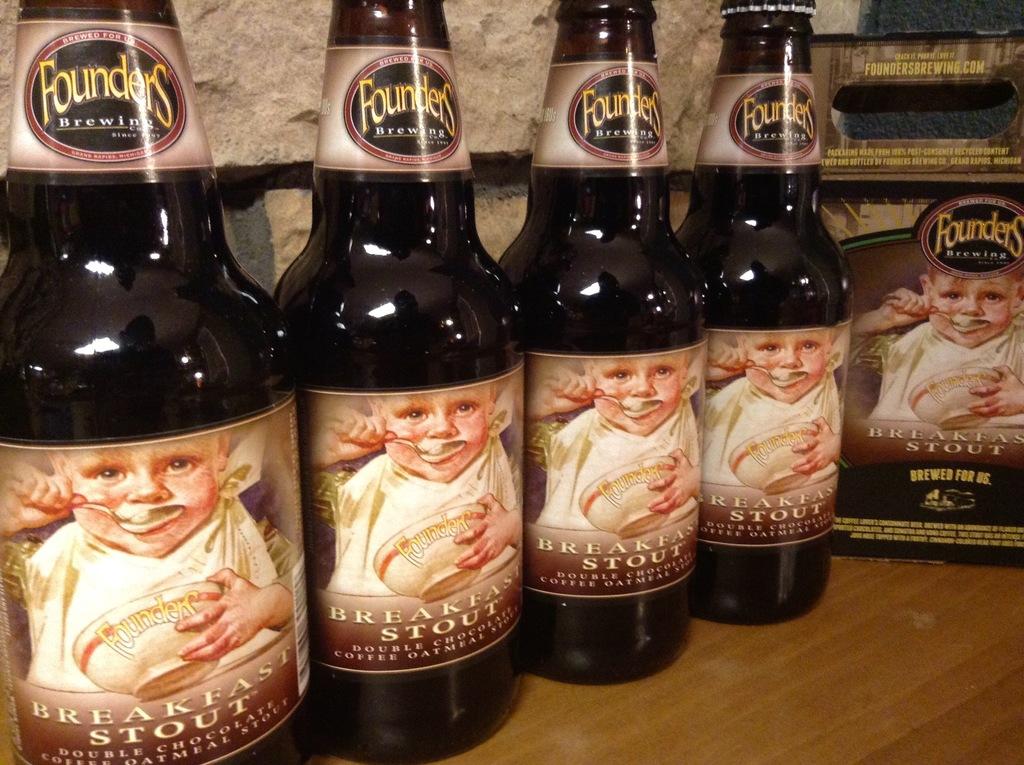Who makes the bottled beverage?
Offer a very short reply. Founders. Is there for breakfast?
Provide a succinct answer. Yes. 